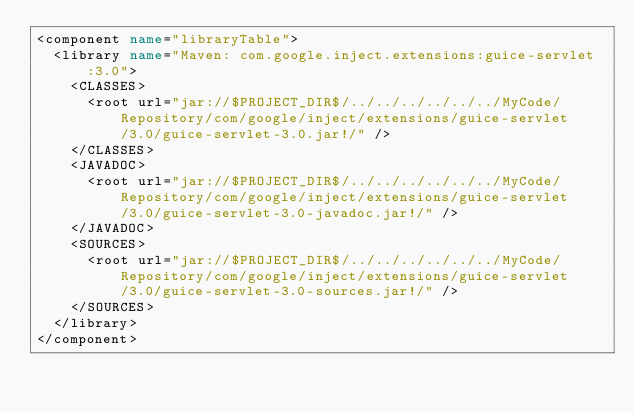Convert code to text. <code><loc_0><loc_0><loc_500><loc_500><_XML_><component name="libraryTable">
  <library name="Maven: com.google.inject.extensions:guice-servlet:3.0">
    <CLASSES>
      <root url="jar://$PROJECT_DIR$/../../../../../../MyCode/Repository/com/google/inject/extensions/guice-servlet/3.0/guice-servlet-3.0.jar!/" />
    </CLASSES>
    <JAVADOC>
      <root url="jar://$PROJECT_DIR$/../../../../../../MyCode/Repository/com/google/inject/extensions/guice-servlet/3.0/guice-servlet-3.0-javadoc.jar!/" />
    </JAVADOC>
    <SOURCES>
      <root url="jar://$PROJECT_DIR$/../../../../../../MyCode/Repository/com/google/inject/extensions/guice-servlet/3.0/guice-servlet-3.0-sources.jar!/" />
    </SOURCES>
  </library>
</component></code> 